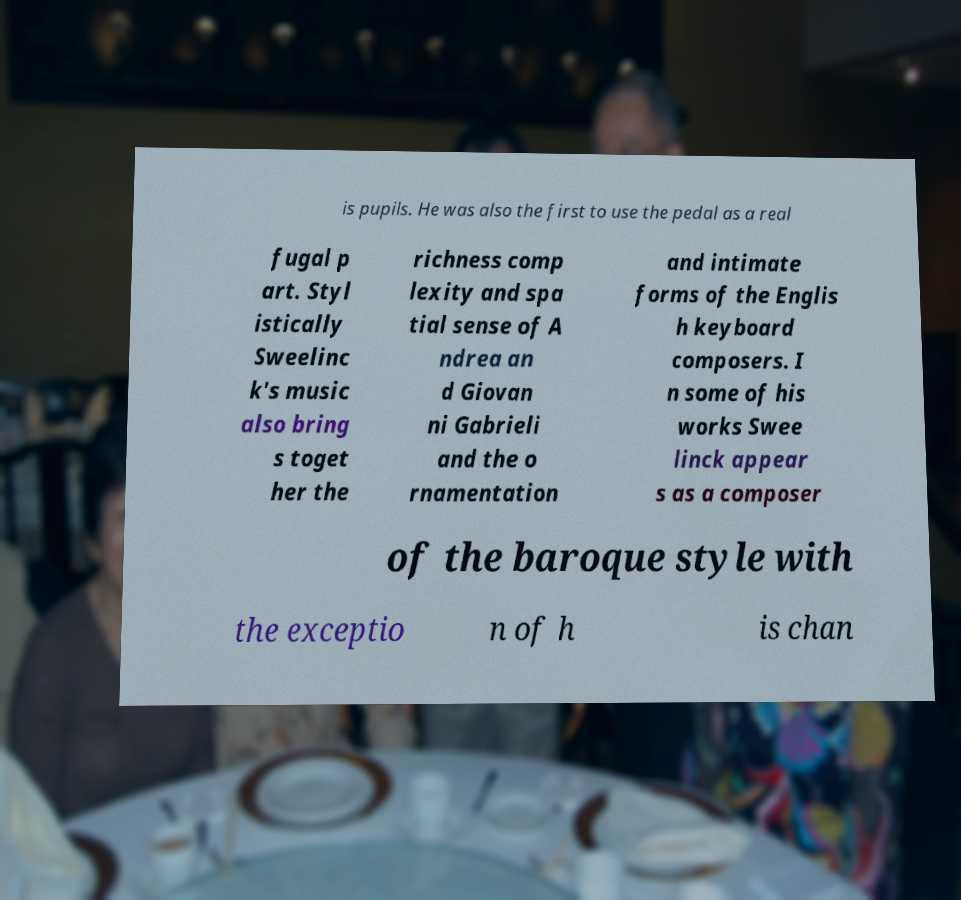Please read and relay the text visible in this image. What does it say? is pupils. He was also the first to use the pedal as a real fugal p art. Styl istically Sweelinc k's music also bring s toget her the richness comp lexity and spa tial sense of A ndrea an d Giovan ni Gabrieli and the o rnamentation and intimate forms of the Englis h keyboard composers. I n some of his works Swee linck appear s as a composer of the baroque style with the exceptio n of h is chan 